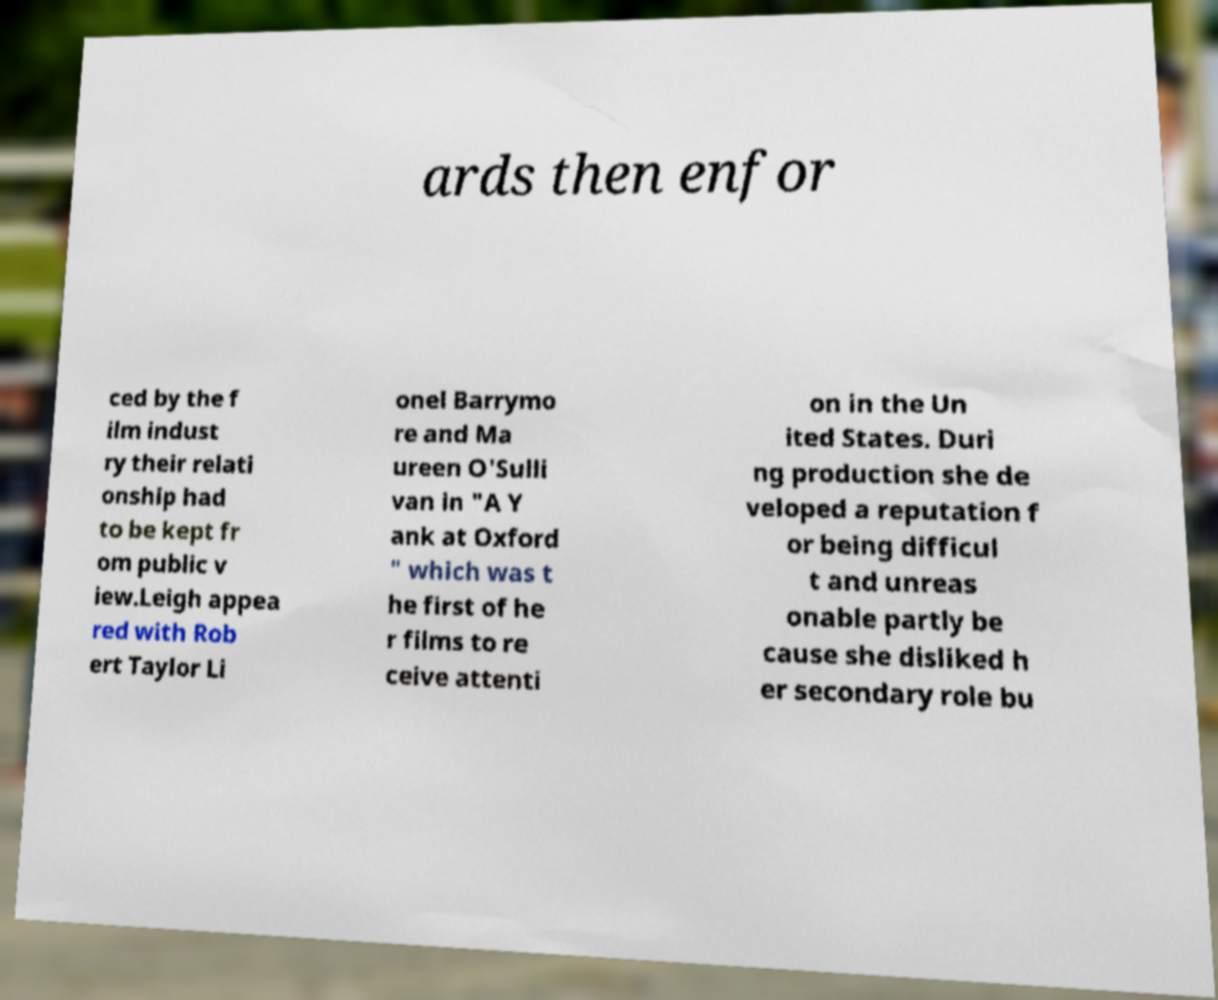What messages or text are displayed in this image? I need them in a readable, typed format. ards then enfor ced by the f ilm indust ry their relati onship had to be kept fr om public v iew.Leigh appea red with Rob ert Taylor Li onel Barrymo re and Ma ureen O'Sulli van in "A Y ank at Oxford " which was t he first of he r films to re ceive attenti on in the Un ited States. Duri ng production she de veloped a reputation f or being difficul t and unreas onable partly be cause she disliked h er secondary role bu 